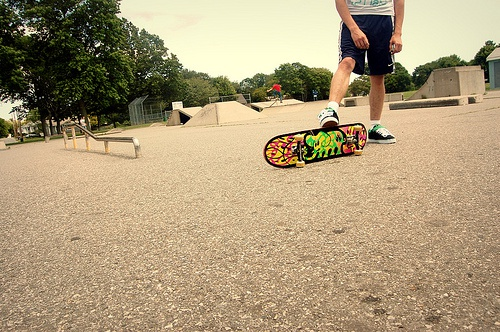Describe the objects in this image and their specific colors. I can see people in gray, black, brown, and tan tones, skateboard in gray, black, gold, orange, and maroon tones, car in gray, olive, tan, and black tones, people in gray, red, black, and teal tones, and car in gray, black, and darkgray tones in this image. 